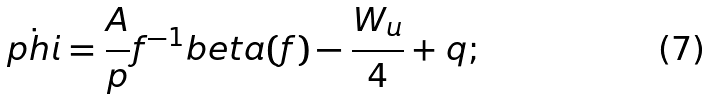Convert formula to latex. <formula><loc_0><loc_0><loc_500><loc_500>\dot { p h i } = \frac { A } { p } f ^ { - 1 } b e t a ( f ) - \frac { W _ { u } } { 4 } + q ;</formula> 